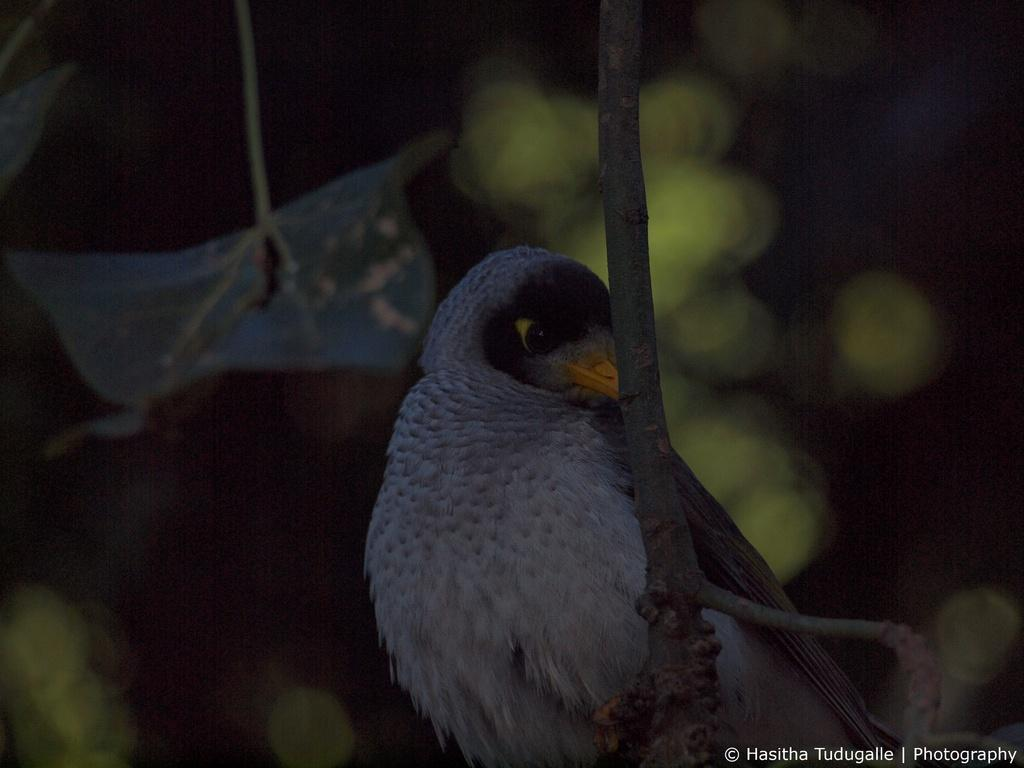What is present on the branch in the image? There is a bird on the branch in the image. Can you describe the bird's appearance? The bird is ash-colored. What else can be seen in the image besides the bird? There are leaves visible in the image. What type of picture is hanging on the wall in the image? There is no mention of a picture or a wall in the provided facts, so we cannot answer this question based on the information given. 